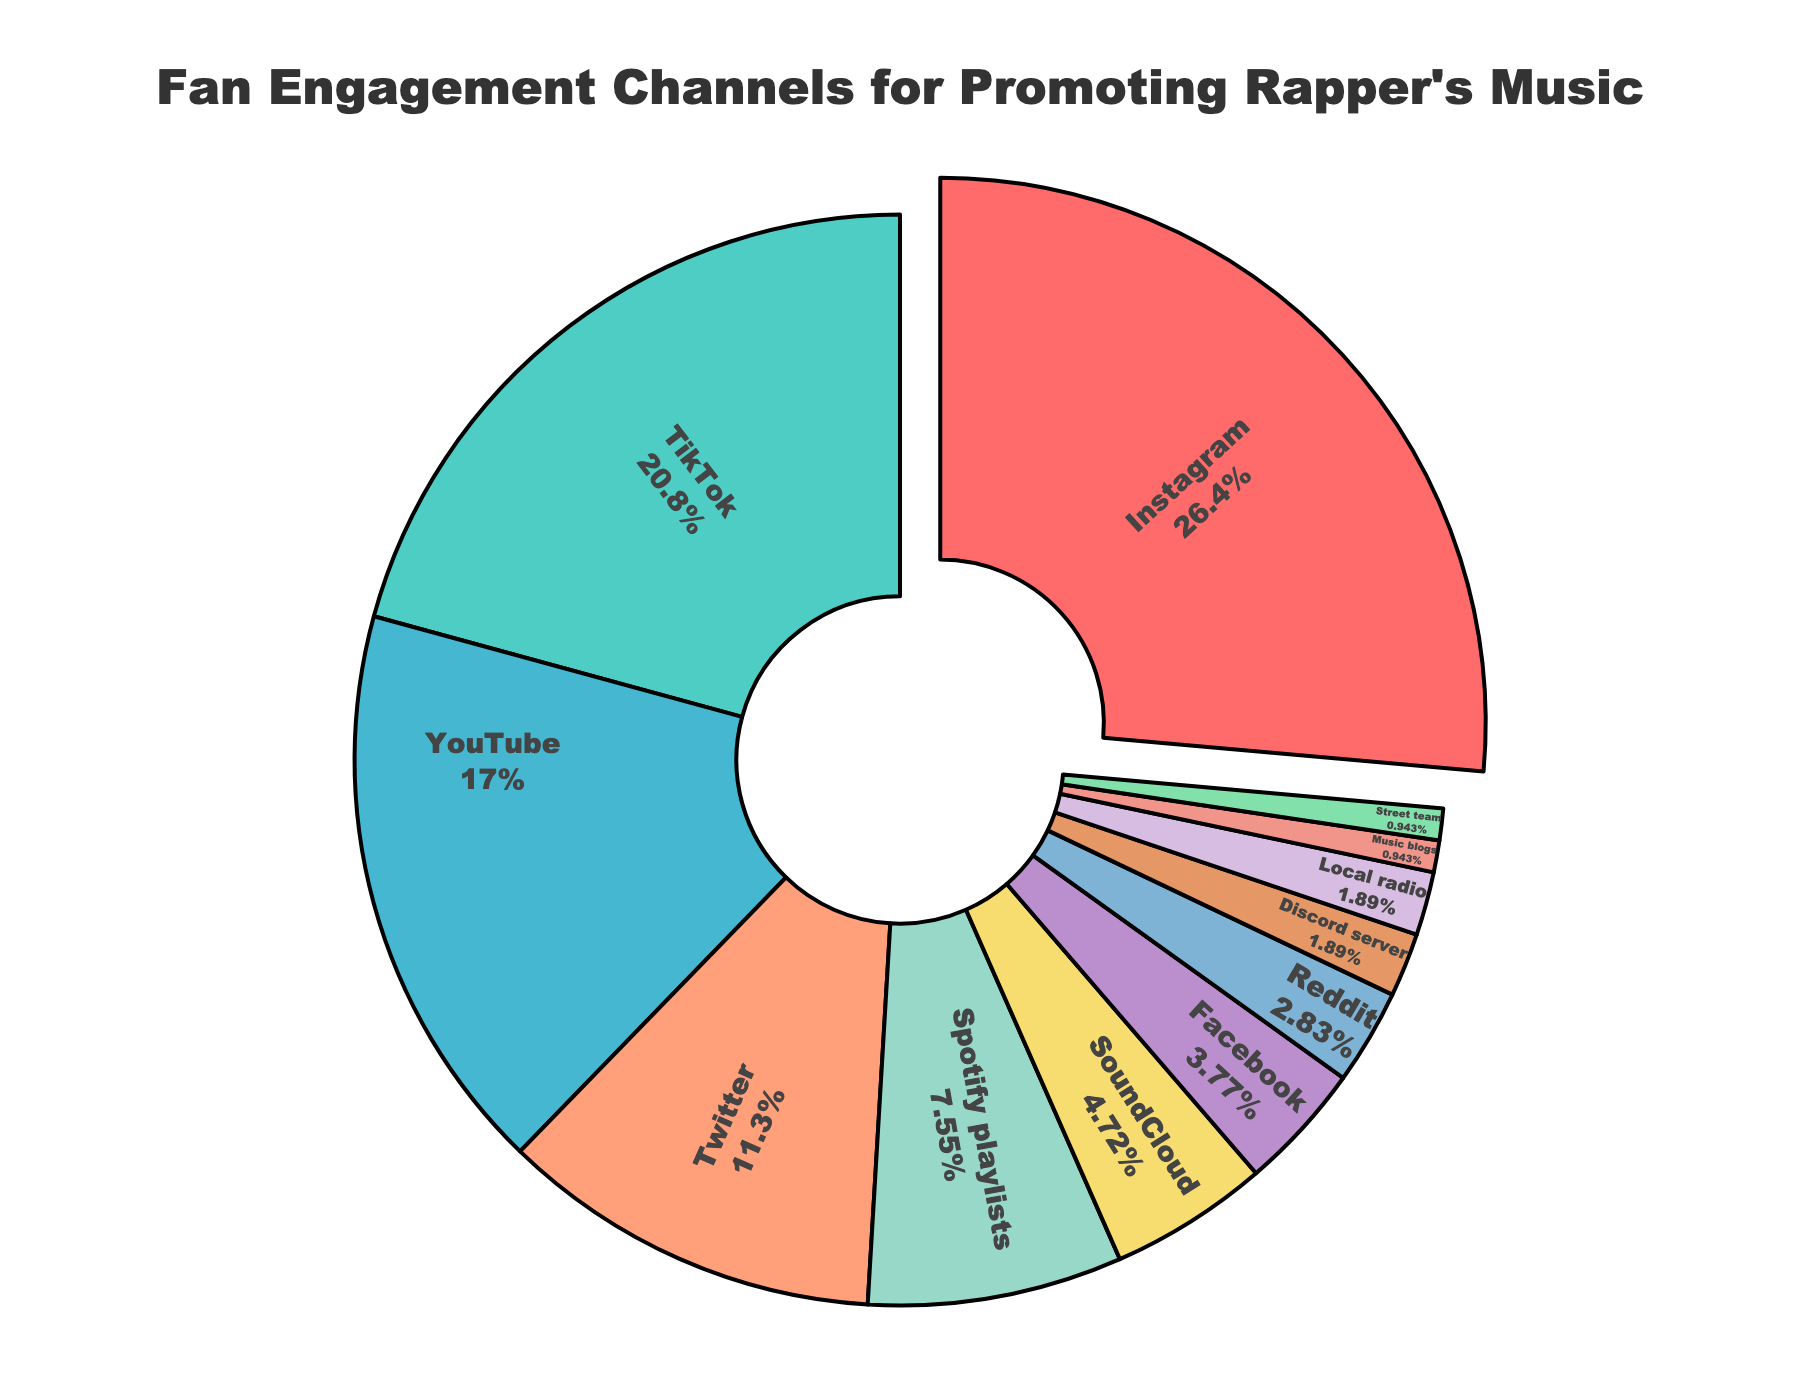What's the most popular engagement channel? The largest percentage slice in the pie chart is for Instagram, indicated by the pulled-out section, showing it stands out as the most significant portion.
Answer: Instagram Which two channels combined account for the highest percentage? The largest two slices in the pie chart are Instagram (28%) and TikTok (22%). Adding these percentages together gives 50%.
Answer: Instagram and TikTok What is the total percentage of channels related to music streaming platforms, namely Spotify playlists and SoundCloud? Spotify playlists account for 8% and SoundCloud for 5%. Adding these percentages together gives 13%.
Answer: 13% Which engagement channel has the smallest percentage? The slice with the smallest percentage is marked as "Street team" with 1%.
Answer: Street team How does the percentage of YouTube compare to Twitter? The percentage for YouTube is 18%, while Twitter is 12%. Comparing these, YouTube's percentage is higher.
Answer: YouTube has a higher percentage than Twitter Which color represents TikTok and what is its percentage? TikTok is represented by a green slice in the pie chart, and its percentage is 22%.
Answer: Green, 22% If we consider visual platforms only (Instagram, TikTok, YouTube), what combined percentage do they hold? Instagram is 28%, TikTok is 22%, and YouTube is 18%. Summing these gives 28% + 22% + 18% = 68%.
Answer: 68% What is the difference between the percentage of Twitter and Facebook? Twitter accounts for 12%, and Facebook accounts for 4%. The difference is 12% - 4% = 8%.
Answer: 8% Which social media channel has about half the engagement of the leading channel, Instagram? TikTok, with 22%, has slightly less than half of Instagram's 28%.
Answer: TikTok What is the total percentage for all channels with 3% or less? Adding up Reddit (3%), Discord server (2%), Local radio (2%), Music blogs (1%), and Street team (1%) gives 3% + 2% + 2% + 1% + 1% = 9%.
Answer: 9% 